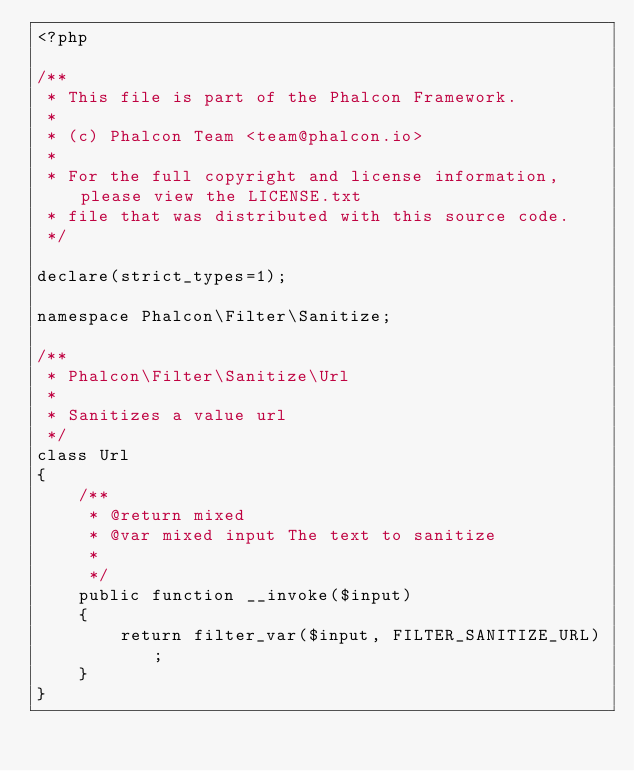Convert code to text. <code><loc_0><loc_0><loc_500><loc_500><_PHP_><?php

/**
 * This file is part of the Phalcon Framework.
 *
 * (c) Phalcon Team <team@phalcon.io>
 *
 * For the full copyright and license information, please view the LICENSE.txt
 * file that was distributed with this source code.
 */

declare(strict_types=1);

namespace Phalcon\Filter\Sanitize;

/**
 * Phalcon\Filter\Sanitize\Url
 *
 * Sanitizes a value url
 */
class Url
{
    /**
     * @return mixed
     * @var mixed input The text to sanitize
     *
     */
    public function __invoke($input)
    {
        return filter_var($input, FILTER_SANITIZE_URL);
    }
}
</code> 